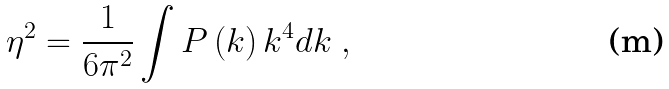Convert formula to latex. <formula><loc_0><loc_0><loc_500><loc_500>\eta ^ { 2 } = \frac { 1 } { 6 \pi ^ { 2 } } \int P \left ( k \right ) k ^ { 4 } d k \ ,</formula> 